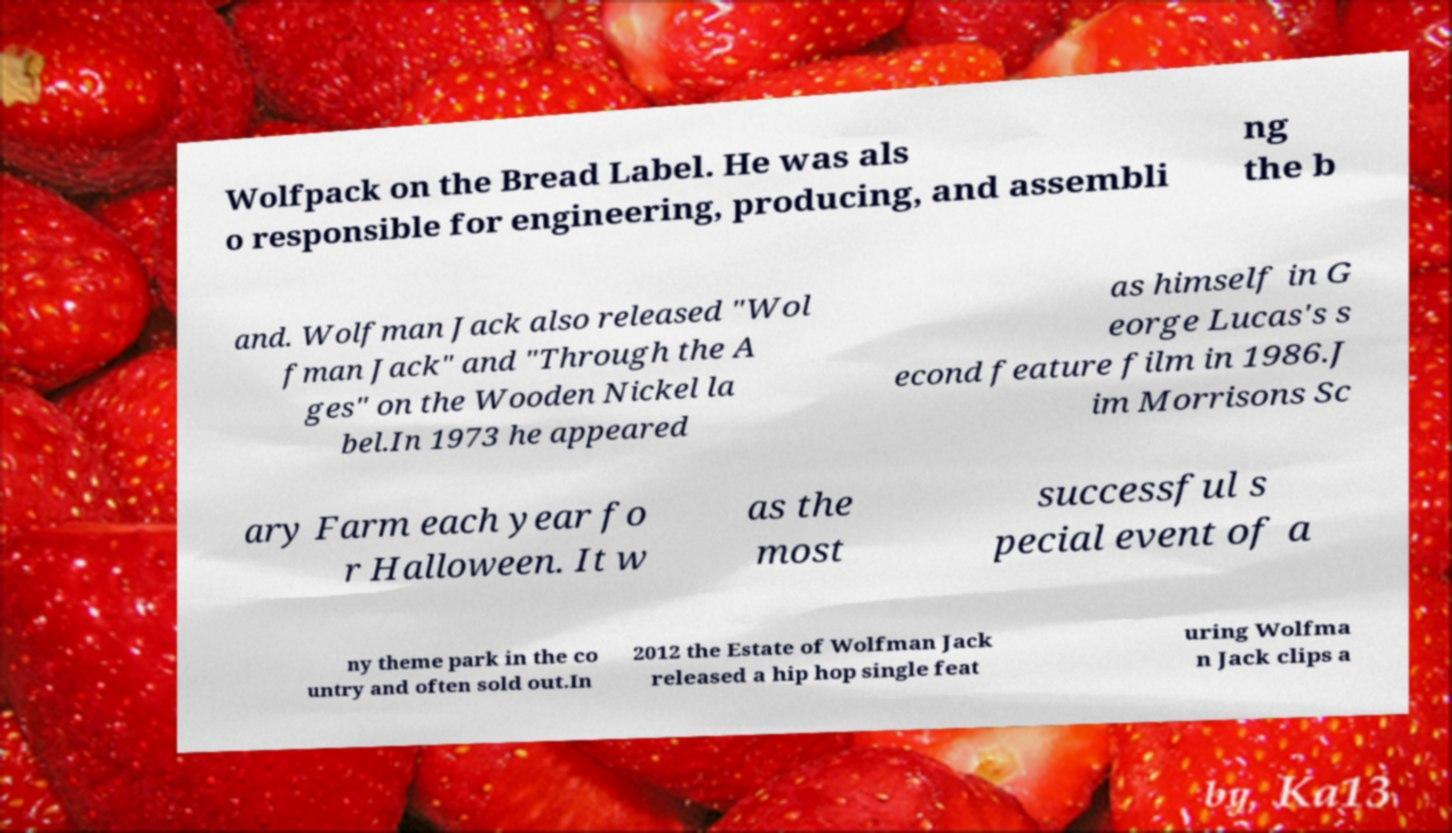Please identify and transcribe the text found in this image. Wolfpack on the Bread Label. He was als o responsible for engineering, producing, and assembli ng the b and. Wolfman Jack also released "Wol fman Jack" and "Through the A ges" on the Wooden Nickel la bel.In 1973 he appeared as himself in G eorge Lucas's s econd feature film in 1986.J im Morrisons Sc ary Farm each year fo r Halloween. It w as the most successful s pecial event of a ny theme park in the co untry and often sold out.In 2012 the Estate of Wolfman Jack released a hip hop single feat uring Wolfma n Jack clips a 